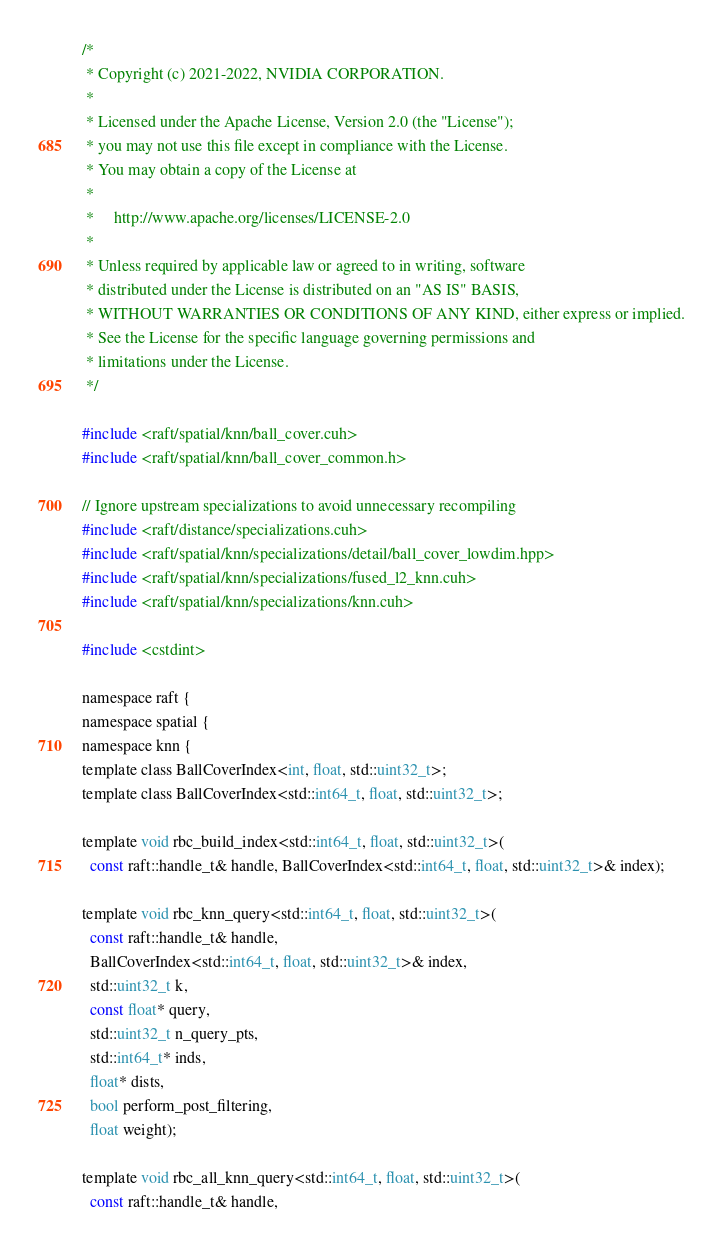<code> <loc_0><loc_0><loc_500><loc_500><_Cuda_>/*
 * Copyright (c) 2021-2022, NVIDIA CORPORATION.
 *
 * Licensed under the Apache License, Version 2.0 (the "License");
 * you may not use this file except in compliance with the License.
 * You may obtain a copy of the License at
 *
 *     http://www.apache.org/licenses/LICENSE-2.0
 *
 * Unless required by applicable law or agreed to in writing, software
 * distributed under the License is distributed on an "AS IS" BASIS,
 * WITHOUT WARRANTIES OR CONDITIONS OF ANY KIND, either express or implied.
 * See the License for the specific language governing permissions and
 * limitations under the License.
 */

#include <raft/spatial/knn/ball_cover.cuh>
#include <raft/spatial/knn/ball_cover_common.h>

// Ignore upstream specializations to avoid unnecessary recompiling
#include <raft/distance/specializations.cuh>
#include <raft/spatial/knn/specializations/detail/ball_cover_lowdim.hpp>
#include <raft/spatial/knn/specializations/fused_l2_knn.cuh>
#include <raft/spatial/knn/specializations/knn.cuh>

#include <cstdint>

namespace raft {
namespace spatial {
namespace knn {
template class BallCoverIndex<int, float, std::uint32_t>;
template class BallCoverIndex<std::int64_t, float, std::uint32_t>;

template void rbc_build_index<std::int64_t, float, std::uint32_t>(
  const raft::handle_t& handle, BallCoverIndex<std::int64_t, float, std::uint32_t>& index);

template void rbc_knn_query<std::int64_t, float, std::uint32_t>(
  const raft::handle_t& handle,
  BallCoverIndex<std::int64_t, float, std::uint32_t>& index,
  std::uint32_t k,
  const float* query,
  std::uint32_t n_query_pts,
  std::int64_t* inds,
  float* dists,
  bool perform_post_filtering,
  float weight);

template void rbc_all_knn_query<std::int64_t, float, std::uint32_t>(
  const raft::handle_t& handle,</code> 